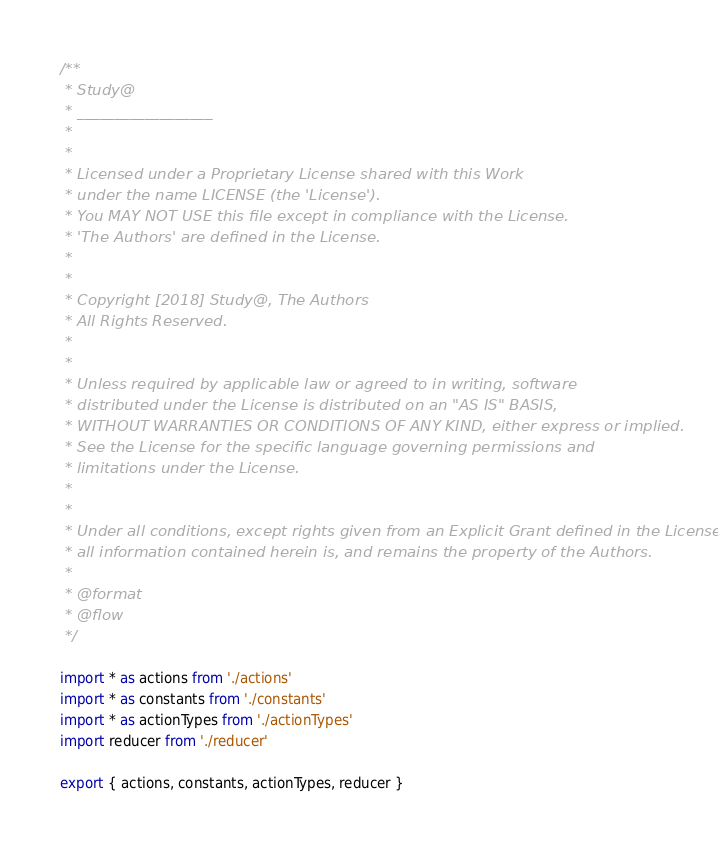<code> <loc_0><loc_0><loc_500><loc_500><_JavaScript_>/**
 * Study@
 * __________________
 *
 *
 * Licensed under a Proprietary License shared with this Work
 * under the name LICENSE (the 'License').
 * You MAY NOT USE this file except in compliance with the License.
 * 'The Authors' are defined in the License.
 *
 *
 * Copyright [2018] Study@, The Authors
 * All Rights Reserved.
 *
 *
 * Unless required by applicable law or agreed to in writing, software
 * distributed under the License is distributed on an "AS IS" BASIS,
 * WITHOUT WARRANTIES OR CONDITIONS OF ANY KIND, either express or implied.
 * See the License for the specific language governing permissions and
 * limitations under the License.
 *
 *
 * Under all conditions, except rights given from an Explicit Grant defined in the License,
 * all information contained herein is, and remains the property of the Authors.
 *
 * @format
 * @flow
 */

import * as actions from './actions'
import * as constants from './constants'
import * as actionTypes from './actionTypes'
import reducer from './reducer'

export { actions, constants, actionTypes, reducer }
</code> 